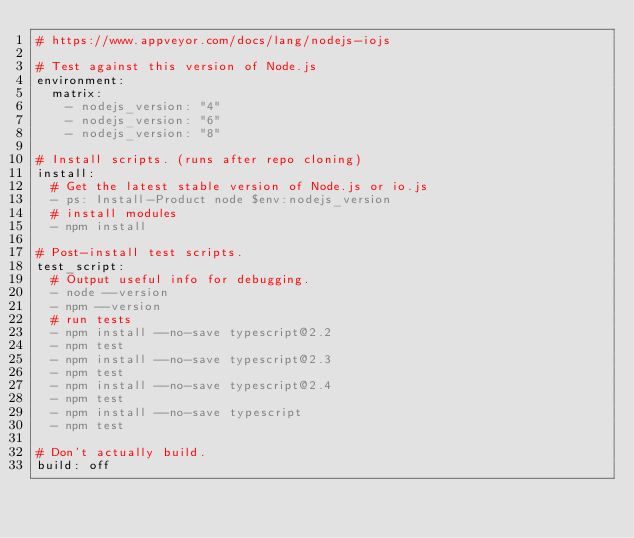Convert code to text. <code><loc_0><loc_0><loc_500><loc_500><_YAML_># https://www.appveyor.com/docs/lang/nodejs-iojs

# Test against this version of Node.js
environment:
  matrix:
    - nodejs_version: "4"
    - nodejs_version: "6"
    - nodejs_version: "8"

# Install scripts. (runs after repo cloning)
install:
  # Get the latest stable version of Node.js or io.js
  - ps: Install-Product node $env:nodejs_version
  # install modules
  - npm install

# Post-install test scripts.
test_script:
  # Output useful info for debugging.
  - node --version
  - npm --version
  # run tests
  - npm install --no-save typescript@2.2
  - npm test
  - npm install --no-save typescript@2.3
  - npm test
  - npm install --no-save typescript@2.4
  - npm test
  - npm install --no-save typescript
  - npm test

# Don't actually build.
build: off
</code> 